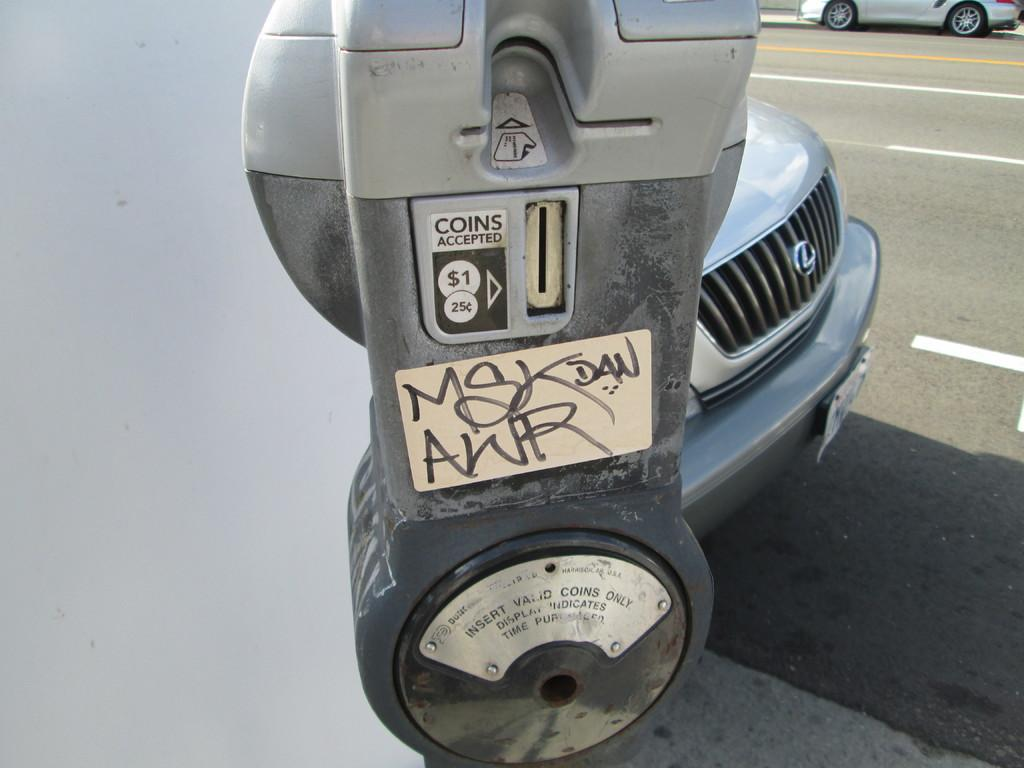<image>
Describe the image concisely. A parking meter that reads coins accepted, $1, 25 cents. 